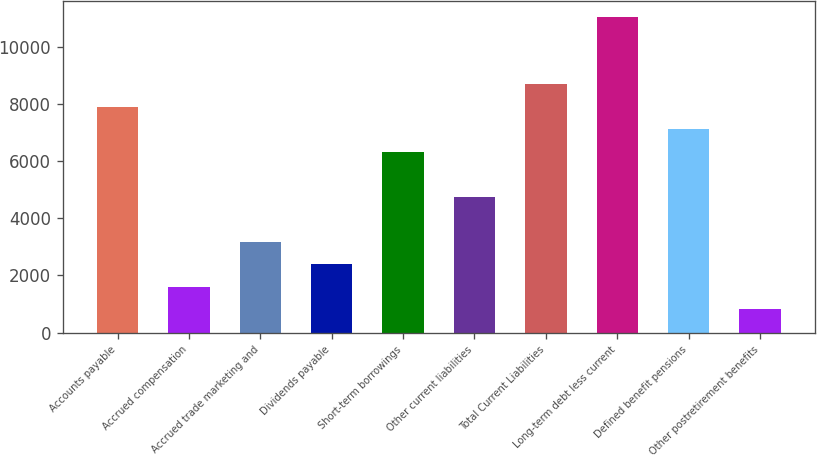Convert chart to OTSL. <chart><loc_0><loc_0><loc_500><loc_500><bar_chart><fcel>Accounts payable<fcel>Accrued compensation<fcel>Accrued trade marketing and<fcel>Dividends payable<fcel>Short-term borrowings<fcel>Other current liabilities<fcel>Total Current Liabilities<fcel>Long-term debt less current<fcel>Defined benefit pensions<fcel>Other postretirement benefits<nl><fcel>7891.1<fcel>1601.34<fcel>3173.78<fcel>2387.56<fcel>6318.66<fcel>4746.22<fcel>8677.32<fcel>11036<fcel>7104.88<fcel>815.12<nl></chart> 